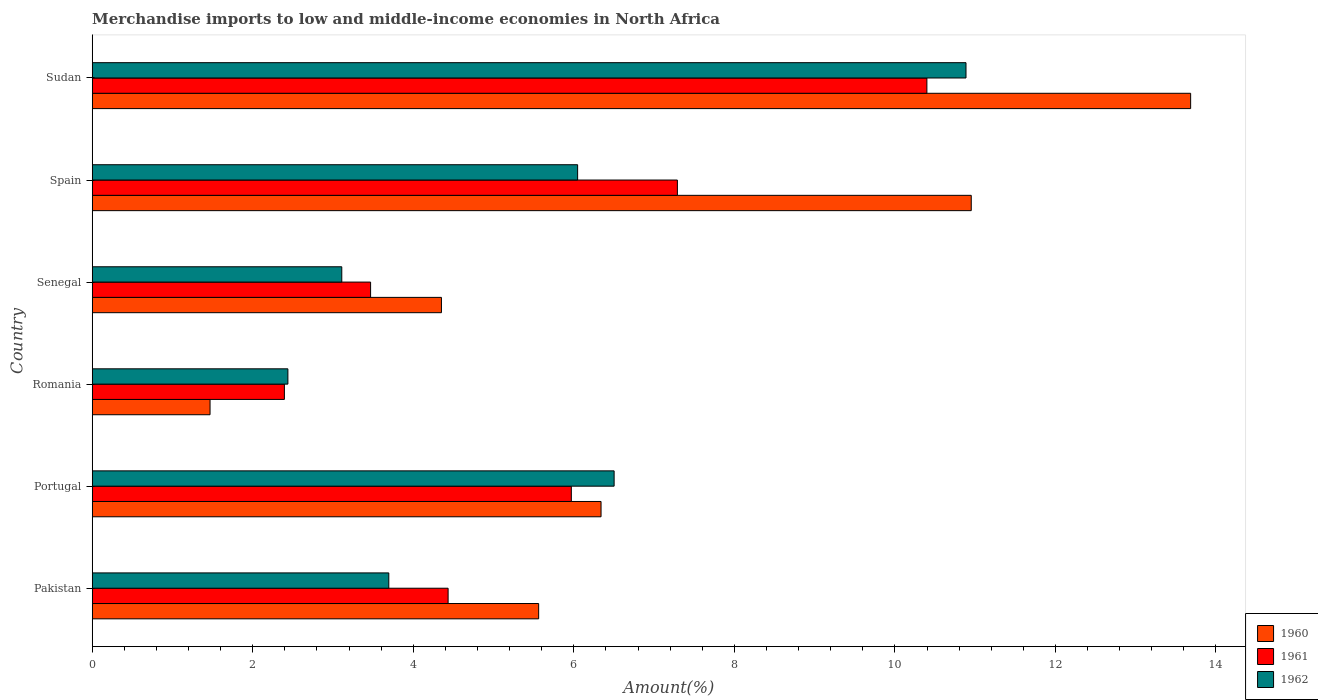How many bars are there on the 5th tick from the bottom?
Your response must be concise. 3. What is the label of the 4th group of bars from the top?
Offer a terse response. Romania. What is the percentage of amount earned from merchandise imports in 1962 in Pakistan?
Ensure brevity in your answer.  3.69. Across all countries, what is the maximum percentage of amount earned from merchandise imports in 1962?
Your response must be concise. 10.89. Across all countries, what is the minimum percentage of amount earned from merchandise imports in 1962?
Your response must be concise. 2.44. In which country was the percentage of amount earned from merchandise imports in 1960 maximum?
Your answer should be compact. Sudan. In which country was the percentage of amount earned from merchandise imports in 1962 minimum?
Your answer should be compact. Romania. What is the total percentage of amount earned from merchandise imports in 1961 in the graph?
Give a very brief answer. 33.95. What is the difference between the percentage of amount earned from merchandise imports in 1960 in Romania and that in Spain?
Make the answer very short. -9.48. What is the difference between the percentage of amount earned from merchandise imports in 1961 in Sudan and the percentage of amount earned from merchandise imports in 1962 in Pakistan?
Your answer should be compact. 6.7. What is the average percentage of amount earned from merchandise imports in 1962 per country?
Offer a terse response. 5.45. What is the difference between the percentage of amount earned from merchandise imports in 1962 and percentage of amount earned from merchandise imports in 1960 in Pakistan?
Ensure brevity in your answer.  -1.87. What is the ratio of the percentage of amount earned from merchandise imports in 1960 in Portugal to that in Spain?
Your response must be concise. 0.58. Is the percentage of amount earned from merchandise imports in 1962 in Pakistan less than that in Sudan?
Provide a short and direct response. Yes. What is the difference between the highest and the second highest percentage of amount earned from merchandise imports in 1962?
Your answer should be compact. 4.38. What is the difference between the highest and the lowest percentage of amount earned from merchandise imports in 1962?
Provide a short and direct response. 8.45. In how many countries, is the percentage of amount earned from merchandise imports in 1962 greater than the average percentage of amount earned from merchandise imports in 1962 taken over all countries?
Offer a terse response. 3. How many bars are there?
Provide a succinct answer. 18. Are all the bars in the graph horizontal?
Offer a very short reply. Yes. How many countries are there in the graph?
Provide a short and direct response. 6. What is the difference between two consecutive major ticks on the X-axis?
Keep it short and to the point. 2. Does the graph contain grids?
Your answer should be compact. No. Where does the legend appear in the graph?
Make the answer very short. Bottom right. How many legend labels are there?
Your answer should be very brief. 3. What is the title of the graph?
Provide a succinct answer. Merchandise imports to low and middle-income economies in North Africa. What is the label or title of the X-axis?
Your answer should be compact. Amount(%). What is the Amount(%) of 1960 in Pakistan?
Offer a terse response. 5.56. What is the Amount(%) of 1961 in Pakistan?
Your answer should be very brief. 4.43. What is the Amount(%) of 1962 in Pakistan?
Ensure brevity in your answer.  3.69. What is the Amount(%) of 1960 in Portugal?
Your answer should be compact. 6.34. What is the Amount(%) in 1961 in Portugal?
Offer a very short reply. 5.97. What is the Amount(%) in 1962 in Portugal?
Your answer should be very brief. 6.5. What is the Amount(%) in 1960 in Romania?
Ensure brevity in your answer.  1.47. What is the Amount(%) of 1961 in Romania?
Keep it short and to the point. 2.39. What is the Amount(%) of 1962 in Romania?
Offer a very short reply. 2.44. What is the Amount(%) of 1960 in Senegal?
Give a very brief answer. 4.35. What is the Amount(%) in 1961 in Senegal?
Provide a succinct answer. 3.47. What is the Amount(%) in 1962 in Senegal?
Your answer should be compact. 3.11. What is the Amount(%) of 1960 in Spain?
Your answer should be very brief. 10.95. What is the Amount(%) in 1961 in Spain?
Make the answer very short. 7.29. What is the Amount(%) in 1962 in Spain?
Offer a terse response. 6.05. What is the Amount(%) in 1960 in Sudan?
Offer a terse response. 13.68. What is the Amount(%) in 1961 in Sudan?
Keep it short and to the point. 10.4. What is the Amount(%) in 1962 in Sudan?
Your response must be concise. 10.89. Across all countries, what is the maximum Amount(%) of 1960?
Your response must be concise. 13.68. Across all countries, what is the maximum Amount(%) in 1961?
Your answer should be very brief. 10.4. Across all countries, what is the maximum Amount(%) in 1962?
Make the answer very short. 10.89. Across all countries, what is the minimum Amount(%) in 1960?
Provide a succinct answer. 1.47. Across all countries, what is the minimum Amount(%) of 1961?
Keep it short and to the point. 2.39. Across all countries, what is the minimum Amount(%) in 1962?
Your answer should be compact. 2.44. What is the total Amount(%) in 1960 in the graph?
Offer a very short reply. 42.35. What is the total Amount(%) of 1961 in the graph?
Make the answer very short. 33.95. What is the total Amount(%) of 1962 in the graph?
Keep it short and to the point. 32.68. What is the difference between the Amount(%) of 1960 in Pakistan and that in Portugal?
Your response must be concise. -0.78. What is the difference between the Amount(%) of 1961 in Pakistan and that in Portugal?
Ensure brevity in your answer.  -1.54. What is the difference between the Amount(%) in 1962 in Pakistan and that in Portugal?
Keep it short and to the point. -2.81. What is the difference between the Amount(%) in 1960 in Pakistan and that in Romania?
Your response must be concise. 4.09. What is the difference between the Amount(%) of 1961 in Pakistan and that in Romania?
Provide a succinct answer. 2.04. What is the difference between the Amount(%) in 1962 in Pakistan and that in Romania?
Your answer should be compact. 1.26. What is the difference between the Amount(%) of 1960 in Pakistan and that in Senegal?
Provide a succinct answer. 1.21. What is the difference between the Amount(%) in 1961 in Pakistan and that in Senegal?
Give a very brief answer. 0.97. What is the difference between the Amount(%) of 1962 in Pakistan and that in Senegal?
Give a very brief answer. 0.59. What is the difference between the Amount(%) of 1960 in Pakistan and that in Spain?
Give a very brief answer. -5.39. What is the difference between the Amount(%) in 1961 in Pakistan and that in Spain?
Offer a very short reply. -2.86. What is the difference between the Amount(%) in 1962 in Pakistan and that in Spain?
Keep it short and to the point. -2.35. What is the difference between the Amount(%) of 1960 in Pakistan and that in Sudan?
Provide a short and direct response. -8.12. What is the difference between the Amount(%) in 1961 in Pakistan and that in Sudan?
Provide a short and direct response. -5.96. What is the difference between the Amount(%) in 1962 in Pakistan and that in Sudan?
Keep it short and to the point. -7.19. What is the difference between the Amount(%) in 1960 in Portugal and that in Romania?
Make the answer very short. 4.87. What is the difference between the Amount(%) of 1961 in Portugal and that in Romania?
Offer a terse response. 3.57. What is the difference between the Amount(%) in 1962 in Portugal and that in Romania?
Your response must be concise. 4.06. What is the difference between the Amount(%) in 1960 in Portugal and that in Senegal?
Your response must be concise. 1.99. What is the difference between the Amount(%) in 1961 in Portugal and that in Senegal?
Keep it short and to the point. 2.5. What is the difference between the Amount(%) of 1962 in Portugal and that in Senegal?
Your response must be concise. 3.39. What is the difference between the Amount(%) in 1960 in Portugal and that in Spain?
Give a very brief answer. -4.61. What is the difference between the Amount(%) in 1961 in Portugal and that in Spain?
Your answer should be very brief. -1.32. What is the difference between the Amount(%) in 1962 in Portugal and that in Spain?
Give a very brief answer. 0.45. What is the difference between the Amount(%) in 1960 in Portugal and that in Sudan?
Your response must be concise. -7.35. What is the difference between the Amount(%) of 1961 in Portugal and that in Sudan?
Offer a very short reply. -4.43. What is the difference between the Amount(%) in 1962 in Portugal and that in Sudan?
Your response must be concise. -4.38. What is the difference between the Amount(%) in 1960 in Romania and that in Senegal?
Offer a very short reply. -2.88. What is the difference between the Amount(%) of 1961 in Romania and that in Senegal?
Your answer should be compact. -1.07. What is the difference between the Amount(%) of 1962 in Romania and that in Senegal?
Your answer should be compact. -0.67. What is the difference between the Amount(%) in 1960 in Romania and that in Spain?
Keep it short and to the point. -9.48. What is the difference between the Amount(%) of 1961 in Romania and that in Spain?
Your answer should be compact. -4.9. What is the difference between the Amount(%) in 1962 in Romania and that in Spain?
Your answer should be compact. -3.61. What is the difference between the Amount(%) in 1960 in Romania and that in Sudan?
Offer a terse response. -12.22. What is the difference between the Amount(%) in 1961 in Romania and that in Sudan?
Provide a succinct answer. -8. What is the difference between the Amount(%) in 1962 in Romania and that in Sudan?
Make the answer very short. -8.45. What is the difference between the Amount(%) of 1960 in Senegal and that in Spain?
Your answer should be compact. -6.6. What is the difference between the Amount(%) in 1961 in Senegal and that in Spain?
Ensure brevity in your answer.  -3.82. What is the difference between the Amount(%) of 1962 in Senegal and that in Spain?
Your response must be concise. -2.94. What is the difference between the Amount(%) in 1960 in Senegal and that in Sudan?
Offer a terse response. -9.33. What is the difference between the Amount(%) of 1961 in Senegal and that in Sudan?
Your response must be concise. -6.93. What is the difference between the Amount(%) in 1962 in Senegal and that in Sudan?
Your response must be concise. -7.78. What is the difference between the Amount(%) of 1960 in Spain and that in Sudan?
Your response must be concise. -2.73. What is the difference between the Amount(%) in 1961 in Spain and that in Sudan?
Offer a terse response. -3.11. What is the difference between the Amount(%) in 1962 in Spain and that in Sudan?
Your response must be concise. -4.84. What is the difference between the Amount(%) in 1960 in Pakistan and the Amount(%) in 1961 in Portugal?
Offer a terse response. -0.41. What is the difference between the Amount(%) in 1960 in Pakistan and the Amount(%) in 1962 in Portugal?
Your answer should be compact. -0.94. What is the difference between the Amount(%) in 1961 in Pakistan and the Amount(%) in 1962 in Portugal?
Your response must be concise. -2.07. What is the difference between the Amount(%) of 1960 in Pakistan and the Amount(%) of 1961 in Romania?
Your answer should be compact. 3.17. What is the difference between the Amount(%) of 1960 in Pakistan and the Amount(%) of 1962 in Romania?
Make the answer very short. 3.12. What is the difference between the Amount(%) of 1961 in Pakistan and the Amount(%) of 1962 in Romania?
Give a very brief answer. 2. What is the difference between the Amount(%) of 1960 in Pakistan and the Amount(%) of 1961 in Senegal?
Ensure brevity in your answer.  2.09. What is the difference between the Amount(%) in 1960 in Pakistan and the Amount(%) in 1962 in Senegal?
Make the answer very short. 2.45. What is the difference between the Amount(%) in 1961 in Pakistan and the Amount(%) in 1962 in Senegal?
Your response must be concise. 1.32. What is the difference between the Amount(%) of 1960 in Pakistan and the Amount(%) of 1961 in Spain?
Your response must be concise. -1.73. What is the difference between the Amount(%) in 1960 in Pakistan and the Amount(%) in 1962 in Spain?
Your answer should be very brief. -0.49. What is the difference between the Amount(%) in 1961 in Pakistan and the Amount(%) in 1962 in Spain?
Ensure brevity in your answer.  -1.61. What is the difference between the Amount(%) in 1960 in Pakistan and the Amount(%) in 1961 in Sudan?
Provide a short and direct response. -4.84. What is the difference between the Amount(%) of 1960 in Pakistan and the Amount(%) of 1962 in Sudan?
Your response must be concise. -5.32. What is the difference between the Amount(%) of 1961 in Pakistan and the Amount(%) of 1962 in Sudan?
Your answer should be compact. -6.45. What is the difference between the Amount(%) of 1960 in Portugal and the Amount(%) of 1961 in Romania?
Your answer should be compact. 3.94. What is the difference between the Amount(%) of 1960 in Portugal and the Amount(%) of 1962 in Romania?
Ensure brevity in your answer.  3.9. What is the difference between the Amount(%) of 1961 in Portugal and the Amount(%) of 1962 in Romania?
Your response must be concise. 3.53. What is the difference between the Amount(%) of 1960 in Portugal and the Amount(%) of 1961 in Senegal?
Offer a very short reply. 2.87. What is the difference between the Amount(%) of 1960 in Portugal and the Amount(%) of 1962 in Senegal?
Give a very brief answer. 3.23. What is the difference between the Amount(%) in 1961 in Portugal and the Amount(%) in 1962 in Senegal?
Provide a short and direct response. 2.86. What is the difference between the Amount(%) in 1960 in Portugal and the Amount(%) in 1961 in Spain?
Ensure brevity in your answer.  -0.95. What is the difference between the Amount(%) in 1960 in Portugal and the Amount(%) in 1962 in Spain?
Make the answer very short. 0.29. What is the difference between the Amount(%) in 1961 in Portugal and the Amount(%) in 1962 in Spain?
Provide a succinct answer. -0.08. What is the difference between the Amount(%) in 1960 in Portugal and the Amount(%) in 1961 in Sudan?
Keep it short and to the point. -4.06. What is the difference between the Amount(%) of 1960 in Portugal and the Amount(%) of 1962 in Sudan?
Provide a succinct answer. -4.55. What is the difference between the Amount(%) in 1961 in Portugal and the Amount(%) in 1962 in Sudan?
Ensure brevity in your answer.  -4.92. What is the difference between the Amount(%) in 1960 in Romania and the Amount(%) in 1961 in Senegal?
Your response must be concise. -2. What is the difference between the Amount(%) in 1960 in Romania and the Amount(%) in 1962 in Senegal?
Ensure brevity in your answer.  -1.64. What is the difference between the Amount(%) of 1961 in Romania and the Amount(%) of 1962 in Senegal?
Provide a short and direct response. -0.71. What is the difference between the Amount(%) in 1960 in Romania and the Amount(%) in 1961 in Spain?
Ensure brevity in your answer.  -5.82. What is the difference between the Amount(%) of 1960 in Romania and the Amount(%) of 1962 in Spain?
Keep it short and to the point. -4.58. What is the difference between the Amount(%) of 1961 in Romania and the Amount(%) of 1962 in Spain?
Provide a succinct answer. -3.65. What is the difference between the Amount(%) of 1960 in Romania and the Amount(%) of 1961 in Sudan?
Provide a succinct answer. -8.93. What is the difference between the Amount(%) in 1960 in Romania and the Amount(%) in 1962 in Sudan?
Give a very brief answer. -9.42. What is the difference between the Amount(%) of 1961 in Romania and the Amount(%) of 1962 in Sudan?
Give a very brief answer. -8.49. What is the difference between the Amount(%) in 1960 in Senegal and the Amount(%) in 1961 in Spain?
Offer a terse response. -2.94. What is the difference between the Amount(%) in 1960 in Senegal and the Amount(%) in 1962 in Spain?
Make the answer very short. -1.7. What is the difference between the Amount(%) of 1961 in Senegal and the Amount(%) of 1962 in Spain?
Keep it short and to the point. -2.58. What is the difference between the Amount(%) in 1960 in Senegal and the Amount(%) in 1961 in Sudan?
Give a very brief answer. -6.05. What is the difference between the Amount(%) in 1960 in Senegal and the Amount(%) in 1962 in Sudan?
Offer a terse response. -6.54. What is the difference between the Amount(%) in 1961 in Senegal and the Amount(%) in 1962 in Sudan?
Your response must be concise. -7.42. What is the difference between the Amount(%) of 1960 in Spain and the Amount(%) of 1961 in Sudan?
Keep it short and to the point. 0.55. What is the difference between the Amount(%) in 1960 in Spain and the Amount(%) in 1962 in Sudan?
Offer a terse response. 0.07. What is the difference between the Amount(%) of 1961 in Spain and the Amount(%) of 1962 in Sudan?
Provide a succinct answer. -3.6. What is the average Amount(%) of 1960 per country?
Offer a very short reply. 7.06. What is the average Amount(%) in 1961 per country?
Give a very brief answer. 5.66. What is the average Amount(%) of 1962 per country?
Offer a terse response. 5.45. What is the difference between the Amount(%) in 1960 and Amount(%) in 1961 in Pakistan?
Your answer should be very brief. 1.13. What is the difference between the Amount(%) of 1960 and Amount(%) of 1962 in Pakistan?
Offer a terse response. 1.87. What is the difference between the Amount(%) of 1961 and Amount(%) of 1962 in Pakistan?
Ensure brevity in your answer.  0.74. What is the difference between the Amount(%) of 1960 and Amount(%) of 1961 in Portugal?
Your response must be concise. 0.37. What is the difference between the Amount(%) of 1960 and Amount(%) of 1962 in Portugal?
Your answer should be very brief. -0.16. What is the difference between the Amount(%) of 1961 and Amount(%) of 1962 in Portugal?
Your answer should be compact. -0.53. What is the difference between the Amount(%) in 1960 and Amount(%) in 1961 in Romania?
Your answer should be compact. -0.93. What is the difference between the Amount(%) of 1960 and Amount(%) of 1962 in Romania?
Offer a terse response. -0.97. What is the difference between the Amount(%) of 1961 and Amount(%) of 1962 in Romania?
Your response must be concise. -0.04. What is the difference between the Amount(%) in 1960 and Amount(%) in 1961 in Senegal?
Provide a short and direct response. 0.88. What is the difference between the Amount(%) in 1960 and Amount(%) in 1962 in Senegal?
Your answer should be very brief. 1.24. What is the difference between the Amount(%) in 1961 and Amount(%) in 1962 in Senegal?
Offer a terse response. 0.36. What is the difference between the Amount(%) in 1960 and Amount(%) in 1961 in Spain?
Keep it short and to the point. 3.66. What is the difference between the Amount(%) in 1960 and Amount(%) in 1962 in Spain?
Give a very brief answer. 4.9. What is the difference between the Amount(%) in 1961 and Amount(%) in 1962 in Spain?
Offer a terse response. 1.24. What is the difference between the Amount(%) in 1960 and Amount(%) in 1961 in Sudan?
Your answer should be very brief. 3.29. What is the difference between the Amount(%) of 1960 and Amount(%) of 1962 in Sudan?
Offer a very short reply. 2.8. What is the difference between the Amount(%) of 1961 and Amount(%) of 1962 in Sudan?
Give a very brief answer. -0.49. What is the ratio of the Amount(%) of 1960 in Pakistan to that in Portugal?
Your answer should be compact. 0.88. What is the ratio of the Amount(%) of 1961 in Pakistan to that in Portugal?
Make the answer very short. 0.74. What is the ratio of the Amount(%) of 1962 in Pakistan to that in Portugal?
Ensure brevity in your answer.  0.57. What is the ratio of the Amount(%) of 1960 in Pakistan to that in Romania?
Offer a very short reply. 3.79. What is the ratio of the Amount(%) in 1961 in Pakistan to that in Romania?
Your response must be concise. 1.85. What is the ratio of the Amount(%) of 1962 in Pakistan to that in Romania?
Your response must be concise. 1.52. What is the ratio of the Amount(%) in 1960 in Pakistan to that in Senegal?
Ensure brevity in your answer.  1.28. What is the ratio of the Amount(%) of 1961 in Pakistan to that in Senegal?
Provide a succinct answer. 1.28. What is the ratio of the Amount(%) in 1962 in Pakistan to that in Senegal?
Give a very brief answer. 1.19. What is the ratio of the Amount(%) in 1960 in Pakistan to that in Spain?
Offer a very short reply. 0.51. What is the ratio of the Amount(%) in 1961 in Pakistan to that in Spain?
Offer a terse response. 0.61. What is the ratio of the Amount(%) of 1962 in Pakistan to that in Spain?
Ensure brevity in your answer.  0.61. What is the ratio of the Amount(%) of 1960 in Pakistan to that in Sudan?
Give a very brief answer. 0.41. What is the ratio of the Amount(%) in 1961 in Pakistan to that in Sudan?
Ensure brevity in your answer.  0.43. What is the ratio of the Amount(%) in 1962 in Pakistan to that in Sudan?
Your response must be concise. 0.34. What is the ratio of the Amount(%) of 1960 in Portugal to that in Romania?
Offer a very short reply. 4.32. What is the ratio of the Amount(%) of 1961 in Portugal to that in Romania?
Your response must be concise. 2.49. What is the ratio of the Amount(%) of 1962 in Portugal to that in Romania?
Make the answer very short. 2.67. What is the ratio of the Amount(%) in 1960 in Portugal to that in Senegal?
Your answer should be very brief. 1.46. What is the ratio of the Amount(%) of 1961 in Portugal to that in Senegal?
Your response must be concise. 1.72. What is the ratio of the Amount(%) of 1962 in Portugal to that in Senegal?
Offer a terse response. 2.09. What is the ratio of the Amount(%) in 1960 in Portugal to that in Spain?
Your response must be concise. 0.58. What is the ratio of the Amount(%) of 1961 in Portugal to that in Spain?
Your response must be concise. 0.82. What is the ratio of the Amount(%) of 1962 in Portugal to that in Spain?
Your answer should be very brief. 1.08. What is the ratio of the Amount(%) in 1960 in Portugal to that in Sudan?
Keep it short and to the point. 0.46. What is the ratio of the Amount(%) in 1961 in Portugal to that in Sudan?
Make the answer very short. 0.57. What is the ratio of the Amount(%) in 1962 in Portugal to that in Sudan?
Provide a succinct answer. 0.6. What is the ratio of the Amount(%) in 1960 in Romania to that in Senegal?
Your answer should be compact. 0.34. What is the ratio of the Amount(%) of 1961 in Romania to that in Senegal?
Offer a terse response. 0.69. What is the ratio of the Amount(%) in 1962 in Romania to that in Senegal?
Provide a short and direct response. 0.78. What is the ratio of the Amount(%) in 1960 in Romania to that in Spain?
Ensure brevity in your answer.  0.13. What is the ratio of the Amount(%) in 1961 in Romania to that in Spain?
Provide a succinct answer. 0.33. What is the ratio of the Amount(%) of 1962 in Romania to that in Spain?
Give a very brief answer. 0.4. What is the ratio of the Amount(%) in 1960 in Romania to that in Sudan?
Offer a very short reply. 0.11. What is the ratio of the Amount(%) in 1961 in Romania to that in Sudan?
Your answer should be compact. 0.23. What is the ratio of the Amount(%) of 1962 in Romania to that in Sudan?
Keep it short and to the point. 0.22. What is the ratio of the Amount(%) in 1960 in Senegal to that in Spain?
Ensure brevity in your answer.  0.4. What is the ratio of the Amount(%) in 1961 in Senegal to that in Spain?
Offer a terse response. 0.48. What is the ratio of the Amount(%) of 1962 in Senegal to that in Spain?
Give a very brief answer. 0.51. What is the ratio of the Amount(%) in 1960 in Senegal to that in Sudan?
Offer a very short reply. 0.32. What is the ratio of the Amount(%) in 1961 in Senegal to that in Sudan?
Ensure brevity in your answer.  0.33. What is the ratio of the Amount(%) in 1962 in Senegal to that in Sudan?
Make the answer very short. 0.29. What is the ratio of the Amount(%) of 1960 in Spain to that in Sudan?
Provide a succinct answer. 0.8. What is the ratio of the Amount(%) of 1961 in Spain to that in Sudan?
Your answer should be compact. 0.7. What is the ratio of the Amount(%) in 1962 in Spain to that in Sudan?
Ensure brevity in your answer.  0.56. What is the difference between the highest and the second highest Amount(%) in 1960?
Your response must be concise. 2.73. What is the difference between the highest and the second highest Amount(%) of 1961?
Your answer should be very brief. 3.11. What is the difference between the highest and the second highest Amount(%) of 1962?
Your answer should be compact. 4.38. What is the difference between the highest and the lowest Amount(%) of 1960?
Offer a terse response. 12.22. What is the difference between the highest and the lowest Amount(%) of 1961?
Provide a succinct answer. 8. What is the difference between the highest and the lowest Amount(%) of 1962?
Provide a succinct answer. 8.45. 